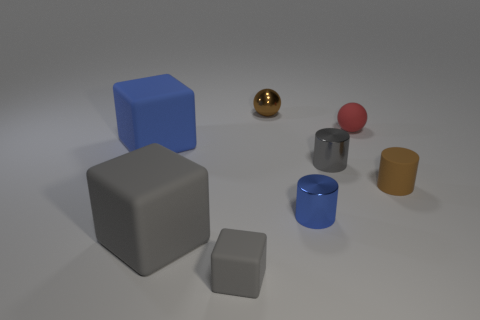Are there fewer tiny cylinders that are in front of the brown cylinder than red things that are to the left of the tiny matte sphere?
Make the answer very short. No. How many other objects are the same material as the big blue thing?
Your response must be concise. 4. There is a gray cube that is the same size as the blue rubber thing; what is it made of?
Offer a terse response. Rubber. Is the number of cubes to the left of the tiny blue shiny cylinder less than the number of brown rubber cylinders?
Make the answer very short. No. There is a gray object on the right side of the small gray object left of the tiny brown thing that is behind the red rubber object; what is its shape?
Your response must be concise. Cylinder. What is the size of the brown thing that is on the right side of the tiny gray metallic thing?
Your response must be concise. Small. The red matte object that is the same size as the metal sphere is what shape?
Give a very brief answer. Sphere. How many objects are either rubber things or large objects in front of the blue block?
Your answer should be compact. 5. What number of gray rubber blocks are in front of the big rubber object that is in front of the tiny cylinder that is behind the small brown rubber thing?
Make the answer very short. 1. What is the color of the cylinder that is the same material as the small red ball?
Keep it short and to the point. Brown. 